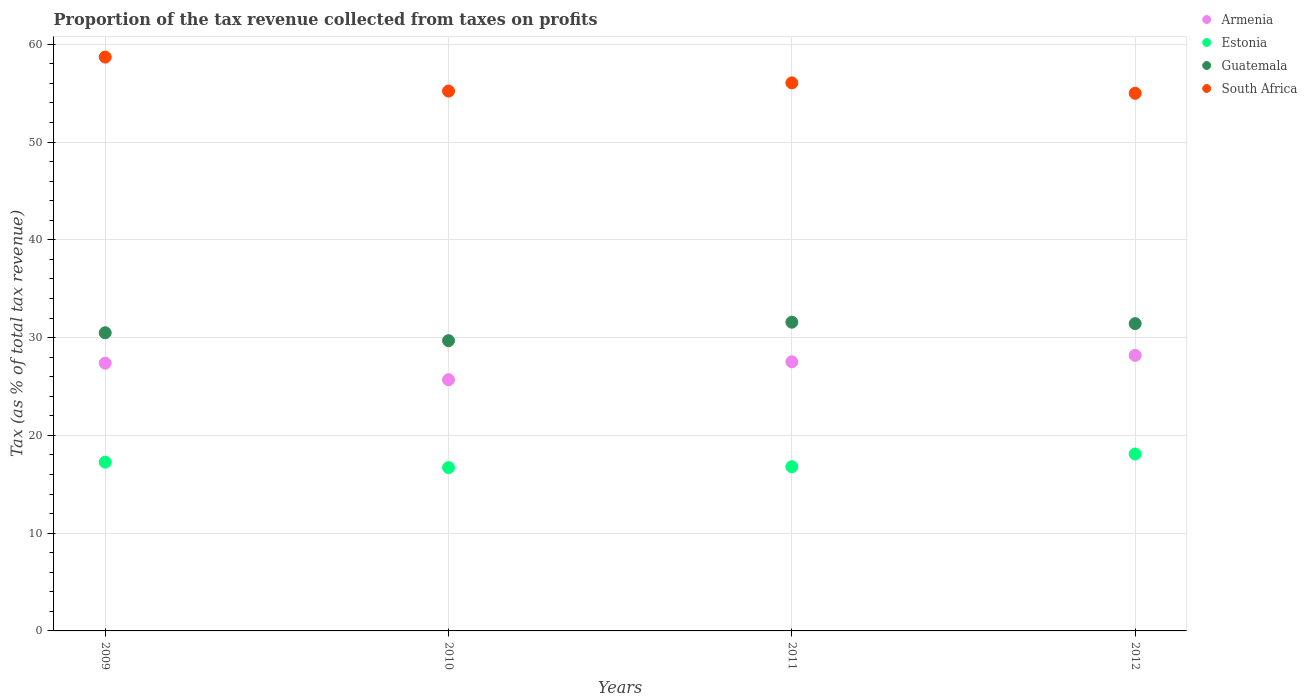Is the number of dotlines equal to the number of legend labels?
Your response must be concise. Yes. What is the proportion of the tax revenue collected in Guatemala in 2009?
Your answer should be very brief. 30.49. Across all years, what is the maximum proportion of the tax revenue collected in Armenia?
Keep it short and to the point. 28.18. Across all years, what is the minimum proportion of the tax revenue collected in Armenia?
Offer a very short reply. 25.69. In which year was the proportion of the tax revenue collected in Guatemala maximum?
Give a very brief answer. 2011. In which year was the proportion of the tax revenue collected in Armenia minimum?
Make the answer very short. 2010. What is the total proportion of the tax revenue collected in Armenia in the graph?
Give a very brief answer. 108.79. What is the difference between the proportion of the tax revenue collected in Estonia in 2011 and that in 2012?
Provide a short and direct response. -1.3. What is the difference between the proportion of the tax revenue collected in Estonia in 2011 and the proportion of the tax revenue collected in Guatemala in 2012?
Keep it short and to the point. -14.64. What is the average proportion of the tax revenue collected in Guatemala per year?
Offer a very short reply. 30.8. In the year 2011, what is the difference between the proportion of the tax revenue collected in Guatemala and proportion of the tax revenue collected in Armenia?
Give a very brief answer. 4.05. What is the ratio of the proportion of the tax revenue collected in Estonia in 2009 to that in 2011?
Your answer should be very brief. 1.03. Is the proportion of the tax revenue collected in Guatemala in 2009 less than that in 2011?
Your answer should be compact. Yes. What is the difference between the highest and the second highest proportion of the tax revenue collected in Armenia?
Your answer should be very brief. 0.66. What is the difference between the highest and the lowest proportion of the tax revenue collected in Armenia?
Keep it short and to the point. 2.49. In how many years, is the proportion of the tax revenue collected in Estonia greater than the average proportion of the tax revenue collected in Estonia taken over all years?
Your response must be concise. 2. Is the proportion of the tax revenue collected in Guatemala strictly greater than the proportion of the tax revenue collected in Estonia over the years?
Give a very brief answer. Yes. Is the proportion of the tax revenue collected in Guatemala strictly less than the proportion of the tax revenue collected in South Africa over the years?
Your response must be concise. Yes. How many dotlines are there?
Your answer should be compact. 4. What is the difference between two consecutive major ticks on the Y-axis?
Make the answer very short. 10. How many legend labels are there?
Make the answer very short. 4. How are the legend labels stacked?
Ensure brevity in your answer.  Vertical. What is the title of the graph?
Offer a terse response. Proportion of the tax revenue collected from taxes on profits. What is the label or title of the Y-axis?
Your answer should be very brief. Tax (as % of total tax revenue). What is the Tax (as % of total tax revenue) of Armenia in 2009?
Your answer should be compact. 27.39. What is the Tax (as % of total tax revenue) of Estonia in 2009?
Provide a short and direct response. 17.26. What is the Tax (as % of total tax revenue) of Guatemala in 2009?
Offer a very short reply. 30.49. What is the Tax (as % of total tax revenue) of South Africa in 2009?
Provide a short and direct response. 58.69. What is the Tax (as % of total tax revenue) of Armenia in 2010?
Offer a terse response. 25.69. What is the Tax (as % of total tax revenue) in Estonia in 2010?
Provide a succinct answer. 16.7. What is the Tax (as % of total tax revenue) of Guatemala in 2010?
Offer a very short reply. 29.69. What is the Tax (as % of total tax revenue) of South Africa in 2010?
Your answer should be compact. 55.21. What is the Tax (as % of total tax revenue) in Armenia in 2011?
Your response must be concise. 27.52. What is the Tax (as % of total tax revenue) of Estonia in 2011?
Your answer should be very brief. 16.79. What is the Tax (as % of total tax revenue) in Guatemala in 2011?
Offer a very short reply. 31.58. What is the Tax (as % of total tax revenue) of South Africa in 2011?
Offer a very short reply. 56.05. What is the Tax (as % of total tax revenue) of Armenia in 2012?
Provide a succinct answer. 28.18. What is the Tax (as % of total tax revenue) of Estonia in 2012?
Your response must be concise. 18.09. What is the Tax (as % of total tax revenue) of Guatemala in 2012?
Give a very brief answer. 31.43. What is the Tax (as % of total tax revenue) of South Africa in 2012?
Make the answer very short. 54.98. Across all years, what is the maximum Tax (as % of total tax revenue) in Armenia?
Make the answer very short. 28.18. Across all years, what is the maximum Tax (as % of total tax revenue) of Estonia?
Offer a terse response. 18.09. Across all years, what is the maximum Tax (as % of total tax revenue) in Guatemala?
Provide a succinct answer. 31.58. Across all years, what is the maximum Tax (as % of total tax revenue) of South Africa?
Offer a terse response. 58.69. Across all years, what is the minimum Tax (as % of total tax revenue) in Armenia?
Offer a terse response. 25.69. Across all years, what is the minimum Tax (as % of total tax revenue) in Estonia?
Ensure brevity in your answer.  16.7. Across all years, what is the minimum Tax (as % of total tax revenue) in Guatemala?
Your answer should be very brief. 29.69. Across all years, what is the minimum Tax (as % of total tax revenue) of South Africa?
Your answer should be very brief. 54.98. What is the total Tax (as % of total tax revenue) in Armenia in the graph?
Keep it short and to the point. 108.79. What is the total Tax (as % of total tax revenue) of Estonia in the graph?
Give a very brief answer. 68.85. What is the total Tax (as % of total tax revenue) of Guatemala in the graph?
Offer a terse response. 123.19. What is the total Tax (as % of total tax revenue) in South Africa in the graph?
Your response must be concise. 224.94. What is the difference between the Tax (as % of total tax revenue) in Armenia in 2009 and that in 2010?
Give a very brief answer. 1.7. What is the difference between the Tax (as % of total tax revenue) in Estonia in 2009 and that in 2010?
Offer a terse response. 0.55. What is the difference between the Tax (as % of total tax revenue) of Guatemala in 2009 and that in 2010?
Make the answer very short. 0.81. What is the difference between the Tax (as % of total tax revenue) in South Africa in 2009 and that in 2010?
Offer a terse response. 3.47. What is the difference between the Tax (as % of total tax revenue) in Armenia in 2009 and that in 2011?
Offer a terse response. -0.14. What is the difference between the Tax (as % of total tax revenue) of Estonia in 2009 and that in 2011?
Your response must be concise. 0.46. What is the difference between the Tax (as % of total tax revenue) in Guatemala in 2009 and that in 2011?
Provide a succinct answer. -1.08. What is the difference between the Tax (as % of total tax revenue) of South Africa in 2009 and that in 2011?
Offer a terse response. 2.63. What is the difference between the Tax (as % of total tax revenue) of Armenia in 2009 and that in 2012?
Offer a terse response. -0.79. What is the difference between the Tax (as % of total tax revenue) of Estonia in 2009 and that in 2012?
Offer a very short reply. -0.84. What is the difference between the Tax (as % of total tax revenue) of Guatemala in 2009 and that in 2012?
Keep it short and to the point. -0.94. What is the difference between the Tax (as % of total tax revenue) of South Africa in 2009 and that in 2012?
Your response must be concise. 3.7. What is the difference between the Tax (as % of total tax revenue) of Armenia in 2010 and that in 2011?
Your answer should be compact. -1.83. What is the difference between the Tax (as % of total tax revenue) in Estonia in 2010 and that in 2011?
Provide a succinct answer. -0.09. What is the difference between the Tax (as % of total tax revenue) in Guatemala in 2010 and that in 2011?
Offer a very short reply. -1.89. What is the difference between the Tax (as % of total tax revenue) of South Africa in 2010 and that in 2011?
Ensure brevity in your answer.  -0.84. What is the difference between the Tax (as % of total tax revenue) of Armenia in 2010 and that in 2012?
Provide a short and direct response. -2.49. What is the difference between the Tax (as % of total tax revenue) in Estonia in 2010 and that in 2012?
Keep it short and to the point. -1.39. What is the difference between the Tax (as % of total tax revenue) of Guatemala in 2010 and that in 2012?
Ensure brevity in your answer.  -1.74. What is the difference between the Tax (as % of total tax revenue) in South Africa in 2010 and that in 2012?
Your answer should be compact. 0.23. What is the difference between the Tax (as % of total tax revenue) of Armenia in 2011 and that in 2012?
Offer a terse response. -0.66. What is the difference between the Tax (as % of total tax revenue) in Estonia in 2011 and that in 2012?
Keep it short and to the point. -1.3. What is the difference between the Tax (as % of total tax revenue) of Guatemala in 2011 and that in 2012?
Provide a succinct answer. 0.14. What is the difference between the Tax (as % of total tax revenue) of South Africa in 2011 and that in 2012?
Give a very brief answer. 1.07. What is the difference between the Tax (as % of total tax revenue) in Armenia in 2009 and the Tax (as % of total tax revenue) in Estonia in 2010?
Keep it short and to the point. 10.69. What is the difference between the Tax (as % of total tax revenue) of Armenia in 2009 and the Tax (as % of total tax revenue) of Guatemala in 2010?
Offer a very short reply. -2.3. What is the difference between the Tax (as % of total tax revenue) in Armenia in 2009 and the Tax (as % of total tax revenue) in South Africa in 2010?
Give a very brief answer. -27.82. What is the difference between the Tax (as % of total tax revenue) of Estonia in 2009 and the Tax (as % of total tax revenue) of Guatemala in 2010?
Your answer should be very brief. -12.43. What is the difference between the Tax (as % of total tax revenue) of Estonia in 2009 and the Tax (as % of total tax revenue) of South Africa in 2010?
Your answer should be compact. -37.95. What is the difference between the Tax (as % of total tax revenue) in Guatemala in 2009 and the Tax (as % of total tax revenue) in South Africa in 2010?
Your answer should be very brief. -24.72. What is the difference between the Tax (as % of total tax revenue) in Armenia in 2009 and the Tax (as % of total tax revenue) in Estonia in 2011?
Your answer should be compact. 10.59. What is the difference between the Tax (as % of total tax revenue) in Armenia in 2009 and the Tax (as % of total tax revenue) in Guatemala in 2011?
Provide a short and direct response. -4.19. What is the difference between the Tax (as % of total tax revenue) in Armenia in 2009 and the Tax (as % of total tax revenue) in South Africa in 2011?
Provide a short and direct response. -28.66. What is the difference between the Tax (as % of total tax revenue) in Estonia in 2009 and the Tax (as % of total tax revenue) in Guatemala in 2011?
Ensure brevity in your answer.  -14.32. What is the difference between the Tax (as % of total tax revenue) in Estonia in 2009 and the Tax (as % of total tax revenue) in South Africa in 2011?
Give a very brief answer. -38.79. What is the difference between the Tax (as % of total tax revenue) in Guatemala in 2009 and the Tax (as % of total tax revenue) in South Africa in 2011?
Your response must be concise. -25.56. What is the difference between the Tax (as % of total tax revenue) of Armenia in 2009 and the Tax (as % of total tax revenue) of Estonia in 2012?
Make the answer very short. 9.29. What is the difference between the Tax (as % of total tax revenue) in Armenia in 2009 and the Tax (as % of total tax revenue) in Guatemala in 2012?
Offer a very short reply. -4.04. What is the difference between the Tax (as % of total tax revenue) in Armenia in 2009 and the Tax (as % of total tax revenue) in South Africa in 2012?
Offer a terse response. -27.6. What is the difference between the Tax (as % of total tax revenue) in Estonia in 2009 and the Tax (as % of total tax revenue) in Guatemala in 2012?
Give a very brief answer. -14.17. What is the difference between the Tax (as % of total tax revenue) in Estonia in 2009 and the Tax (as % of total tax revenue) in South Africa in 2012?
Your answer should be very brief. -37.73. What is the difference between the Tax (as % of total tax revenue) of Guatemala in 2009 and the Tax (as % of total tax revenue) of South Africa in 2012?
Make the answer very short. -24.49. What is the difference between the Tax (as % of total tax revenue) in Armenia in 2010 and the Tax (as % of total tax revenue) in Estonia in 2011?
Keep it short and to the point. 8.9. What is the difference between the Tax (as % of total tax revenue) in Armenia in 2010 and the Tax (as % of total tax revenue) in Guatemala in 2011?
Offer a very short reply. -5.88. What is the difference between the Tax (as % of total tax revenue) in Armenia in 2010 and the Tax (as % of total tax revenue) in South Africa in 2011?
Keep it short and to the point. -30.36. What is the difference between the Tax (as % of total tax revenue) of Estonia in 2010 and the Tax (as % of total tax revenue) of Guatemala in 2011?
Provide a succinct answer. -14.87. What is the difference between the Tax (as % of total tax revenue) of Estonia in 2010 and the Tax (as % of total tax revenue) of South Africa in 2011?
Make the answer very short. -39.35. What is the difference between the Tax (as % of total tax revenue) of Guatemala in 2010 and the Tax (as % of total tax revenue) of South Africa in 2011?
Provide a succinct answer. -26.36. What is the difference between the Tax (as % of total tax revenue) of Armenia in 2010 and the Tax (as % of total tax revenue) of Estonia in 2012?
Give a very brief answer. 7.6. What is the difference between the Tax (as % of total tax revenue) of Armenia in 2010 and the Tax (as % of total tax revenue) of Guatemala in 2012?
Ensure brevity in your answer.  -5.74. What is the difference between the Tax (as % of total tax revenue) of Armenia in 2010 and the Tax (as % of total tax revenue) of South Africa in 2012?
Give a very brief answer. -29.29. What is the difference between the Tax (as % of total tax revenue) of Estonia in 2010 and the Tax (as % of total tax revenue) of Guatemala in 2012?
Provide a succinct answer. -14.73. What is the difference between the Tax (as % of total tax revenue) of Estonia in 2010 and the Tax (as % of total tax revenue) of South Africa in 2012?
Offer a very short reply. -38.28. What is the difference between the Tax (as % of total tax revenue) in Guatemala in 2010 and the Tax (as % of total tax revenue) in South Africa in 2012?
Provide a short and direct response. -25.3. What is the difference between the Tax (as % of total tax revenue) in Armenia in 2011 and the Tax (as % of total tax revenue) in Estonia in 2012?
Offer a very short reply. 9.43. What is the difference between the Tax (as % of total tax revenue) of Armenia in 2011 and the Tax (as % of total tax revenue) of Guatemala in 2012?
Your answer should be compact. -3.91. What is the difference between the Tax (as % of total tax revenue) in Armenia in 2011 and the Tax (as % of total tax revenue) in South Africa in 2012?
Offer a terse response. -27.46. What is the difference between the Tax (as % of total tax revenue) in Estonia in 2011 and the Tax (as % of total tax revenue) in Guatemala in 2012?
Ensure brevity in your answer.  -14.64. What is the difference between the Tax (as % of total tax revenue) in Estonia in 2011 and the Tax (as % of total tax revenue) in South Africa in 2012?
Your response must be concise. -38.19. What is the difference between the Tax (as % of total tax revenue) of Guatemala in 2011 and the Tax (as % of total tax revenue) of South Africa in 2012?
Your answer should be very brief. -23.41. What is the average Tax (as % of total tax revenue) in Armenia per year?
Give a very brief answer. 27.2. What is the average Tax (as % of total tax revenue) in Estonia per year?
Ensure brevity in your answer.  17.21. What is the average Tax (as % of total tax revenue) of Guatemala per year?
Give a very brief answer. 30.8. What is the average Tax (as % of total tax revenue) in South Africa per year?
Keep it short and to the point. 56.23. In the year 2009, what is the difference between the Tax (as % of total tax revenue) of Armenia and Tax (as % of total tax revenue) of Estonia?
Keep it short and to the point. 10.13. In the year 2009, what is the difference between the Tax (as % of total tax revenue) in Armenia and Tax (as % of total tax revenue) in Guatemala?
Provide a succinct answer. -3.1. In the year 2009, what is the difference between the Tax (as % of total tax revenue) in Armenia and Tax (as % of total tax revenue) in South Africa?
Offer a terse response. -31.3. In the year 2009, what is the difference between the Tax (as % of total tax revenue) in Estonia and Tax (as % of total tax revenue) in Guatemala?
Offer a very short reply. -13.24. In the year 2009, what is the difference between the Tax (as % of total tax revenue) of Estonia and Tax (as % of total tax revenue) of South Africa?
Provide a succinct answer. -41.43. In the year 2009, what is the difference between the Tax (as % of total tax revenue) in Guatemala and Tax (as % of total tax revenue) in South Africa?
Your response must be concise. -28.19. In the year 2010, what is the difference between the Tax (as % of total tax revenue) in Armenia and Tax (as % of total tax revenue) in Estonia?
Ensure brevity in your answer.  8.99. In the year 2010, what is the difference between the Tax (as % of total tax revenue) of Armenia and Tax (as % of total tax revenue) of Guatemala?
Offer a very short reply. -4. In the year 2010, what is the difference between the Tax (as % of total tax revenue) in Armenia and Tax (as % of total tax revenue) in South Africa?
Offer a terse response. -29.52. In the year 2010, what is the difference between the Tax (as % of total tax revenue) in Estonia and Tax (as % of total tax revenue) in Guatemala?
Offer a very short reply. -12.98. In the year 2010, what is the difference between the Tax (as % of total tax revenue) in Estonia and Tax (as % of total tax revenue) in South Africa?
Keep it short and to the point. -38.51. In the year 2010, what is the difference between the Tax (as % of total tax revenue) in Guatemala and Tax (as % of total tax revenue) in South Africa?
Ensure brevity in your answer.  -25.52. In the year 2011, what is the difference between the Tax (as % of total tax revenue) in Armenia and Tax (as % of total tax revenue) in Estonia?
Your answer should be compact. 10.73. In the year 2011, what is the difference between the Tax (as % of total tax revenue) of Armenia and Tax (as % of total tax revenue) of Guatemala?
Offer a terse response. -4.05. In the year 2011, what is the difference between the Tax (as % of total tax revenue) in Armenia and Tax (as % of total tax revenue) in South Africa?
Give a very brief answer. -28.53. In the year 2011, what is the difference between the Tax (as % of total tax revenue) of Estonia and Tax (as % of total tax revenue) of Guatemala?
Offer a very short reply. -14.78. In the year 2011, what is the difference between the Tax (as % of total tax revenue) of Estonia and Tax (as % of total tax revenue) of South Africa?
Keep it short and to the point. -39.26. In the year 2011, what is the difference between the Tax (as % of total tax revenue) of Guatemala and Tax (as % of total tax revenue) of South Africa?
Provide a short and direct response. -24.48. In the year 2012, what is the difference between the Tax (as % of total tax revenue) in Armenia and Tax (as % of total tax revenue) in Estonia?
Ensure brevity in your answer.  10.09. In the year 2012, what is the difference between the Tax (as % of total tax revenue) of Armenia and Tax (as % of total tax revenue) of Guatemala?
Ensure brevity in your answer.  -3.25. In the year 2012, what is the difference between the Tax (as % of total tax revenue) in Armenia and Tax (as % of total tax revenue) in South Africa?
Offer a very short reply. -26.8. In the year 2012, what is the difference between the Tax (as % of total tax revenue) of Estonia and Tax (as % of total tax revenue) of Guatemala?
Make the answer very short. -13.34. In the year 2012, what is the difference between the Tax (as % of total tax revenue) of Estonia and Tax (as % of total tax revenue) of South Africa?
Your answer should be compact. -36.89. In the year 2012, what is the difference between the Tax (as % of total tax revenue) of Guatemala and Tax (as % of total tax revenue) of South Africa?
Make the answer very short. -23.55. What is the ratio of the Tax (as % of total tax revenue) in Armenia in 2009 to that in 2010?
Provide a succinct answer. 1.07. What is the ratio of the Tax (as % of total tax revenue) of Estonia in 2009 to that in 2010?
Your answer should be very brief. 1.03. What is the ratio of the Tax (as % of total tax revenue) in Guatemala in 2009 to that in 2010?
Offer a terse response. 1.03. What is the ratio of the Tax (as % of total tax revenue) in South Africa in 2009 to that in 2010?
Offer a very short reply. 1.06. What is the ratio of the Tax (as % of total tax revenue) in Armenia in 2009 to that in 2011?
Your answer should be very brief. 1. What is the ratio of the Tax (as % of total tax revenue) of Estonia in 2009 to that in 2011?
Provide a succinct answer. 1.03. What is the ratio of the Tax (as % of total tax revenue) in Guatemala in 2009 to that in 2011?
Give a very brief answer. 0.97. What is the ratio of the Tax (as % of total tax revenue) of South Africa in 2009 to that in 2011?
Make the answer very short. 1.05. What is the ratio of the Tax (as % of total tax revenue) in Armenia in 2009 to that in 2012?
Provide a succinct answer. 0.97. What is the ratio of the Tax (as % of total tax revenue) in Estonia in 2009 to that in 2012?
Provide a succinct answer. 0.95. What is the ratio of the Tax (as % of total tax revenue) in Guatemala in 2009 to that in 2012?
Make the answer very short. 0.97. What is the ratio of the Tax (as % of total tax revenue) of South Africa in 2009 to that in 2012?
Your answer should be compact. 1.07. What is the ratio of the Tax (as % of total tax revenue) of Armenia in 2010 to that in 2011?
Your answer should be compact. 0.93. What is the ratio of the Tax (as % of total tax revenue) in Estonia in 2010 to that in 2011?
Your answer should be very brief. 0.99. What is the ratio of the Tax (as % of total tax revenue) of Guatemala in 2010 to that in 2011?
Provide a short and direct response. 0.94. What is the ratio of the Tax (as % of total tax revenue) of Armenia in 2010 to that in 2012?
Make the answer very short. 0.91. What is the ratio of the Tax (as % of total tax revenue) in Estonia in 2010 to that in 2012?
Your answer should be very brief. 0.92. What is the ratio of the Tax (as % of total tax revenue) in Guatemala in 2010 to that in 2012?
Give a very brief answer. 0.94. What is the ratio of the Tax (as % of total tax revenue) in Armenia in 2011 to that in 2012?
Offer a terse response. 0.98. What is the ratio of the Tax (as % of total tax revenue) in Estonia in 2011 to that in 2012?
Keep it short and to the point. 0.93. What is the ratio of the Tax (as % of total tax revenue) of South Africa in 2011 to that in 2012?
Your answer should be very brief. 1.02. What is the difference between the highest and the second highest Tax (as % of total tax revenue) in Armenia?
Your answer should be compact. 0.66. What is the difference between the highest and the second highest Tax (as % of total tax revenue) of Estonia?
Keep it short and to the point. 0.84. What is the difference between the highest and the second highest Tax (as % of total tax revenue) in Guatemala?
Your answer should be very brief. 0.14. What is the difference between the highest and the second highest Tax (as % of total tax revenue) of South Africa?
Make the answer very short. 2.63. What is the difference between the highest and the lowest Tax (as % of total tax revenue) in Armenia?
Your answer should be very brief. 2.49. What is the difference between the highest and the lowest Tax (as % of total tax revenue) in Estonia?
Your answer should be very brief. 1.39. What is the difference between the highest and the lowest Tax (as % of total tax revenue) of Guatemala?
Offer a very short reply. 1.89. What is the difference between the highest and the lowest Tax (as % of total tax revenue) of South Africa?
Your answer should be very brief. 3.7. 